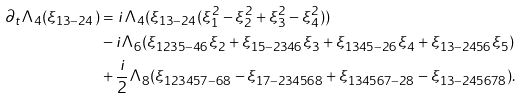Convert formula to latex. <formula><loc_0><loc_0><loc_500><loc_500>\partial _ { t } \Lambda _ { 4 } ( \xi _ { 1 3 - 2 4 } ) & = i \Lambda _ { 4 } ( \xi _ { 1 3 - 2 4 } ( \xi _ { 1 } ^ { 2 } - \xi _ { 2 } ^ { 2 } + \xi _ { 3 } ^ { 2 } - \xi _ { 4 } ^ { 2 } ) ) \\ & - i \Lambda _ { 6 } ( \xi _ { 1 2 3 5 - 4 6 } \xi _ { 2 } + \xi _ { 1 5 - 2 3 4 6 } \xi _ { 3 } + \xi _ { 1 3 4 5 - 2 6 } \xi _ { 4 } + \xi _ { 1 3 - 2 4 5 6 } \xi _ { 5 } ) \\ & + \frac { i } { 2 } \Lambda _ { 8 } ( \xi _ { 1 2 3 4 5 7 - 6 8 } - \xi _ { 1 7 - 2 3 4 5 6 8 } + \xi _ { 1 3 4 5 6 7 - 2 8 } - \xi _ { 1 3 - 2 4 5 6 7 8 } ) .</formula> 